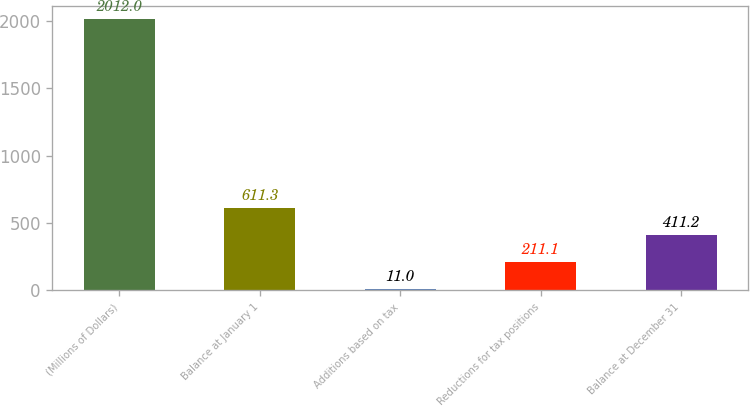Convert chart. <chart><loc_0><loc_0><loc_500><loc_500><bar_chart><fcel>(Millions of Dollars)<fcel>Balance at January 1<fcel>Additions based on tax<fcel>Reductions for tax positions<fcel>Balance at December 31<nl><fcel>2012<fcel>611.3<fcel>11<fcel>211.1<fcel>411.2<nl></chart> 